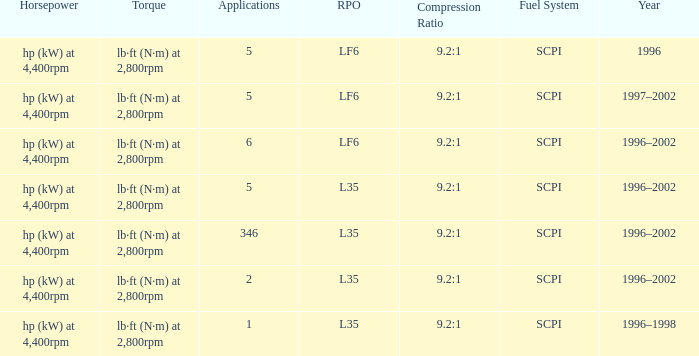What are the torque characteristics of the model made in 1996? Lb·ft (n·m) at 2,800rpm. 